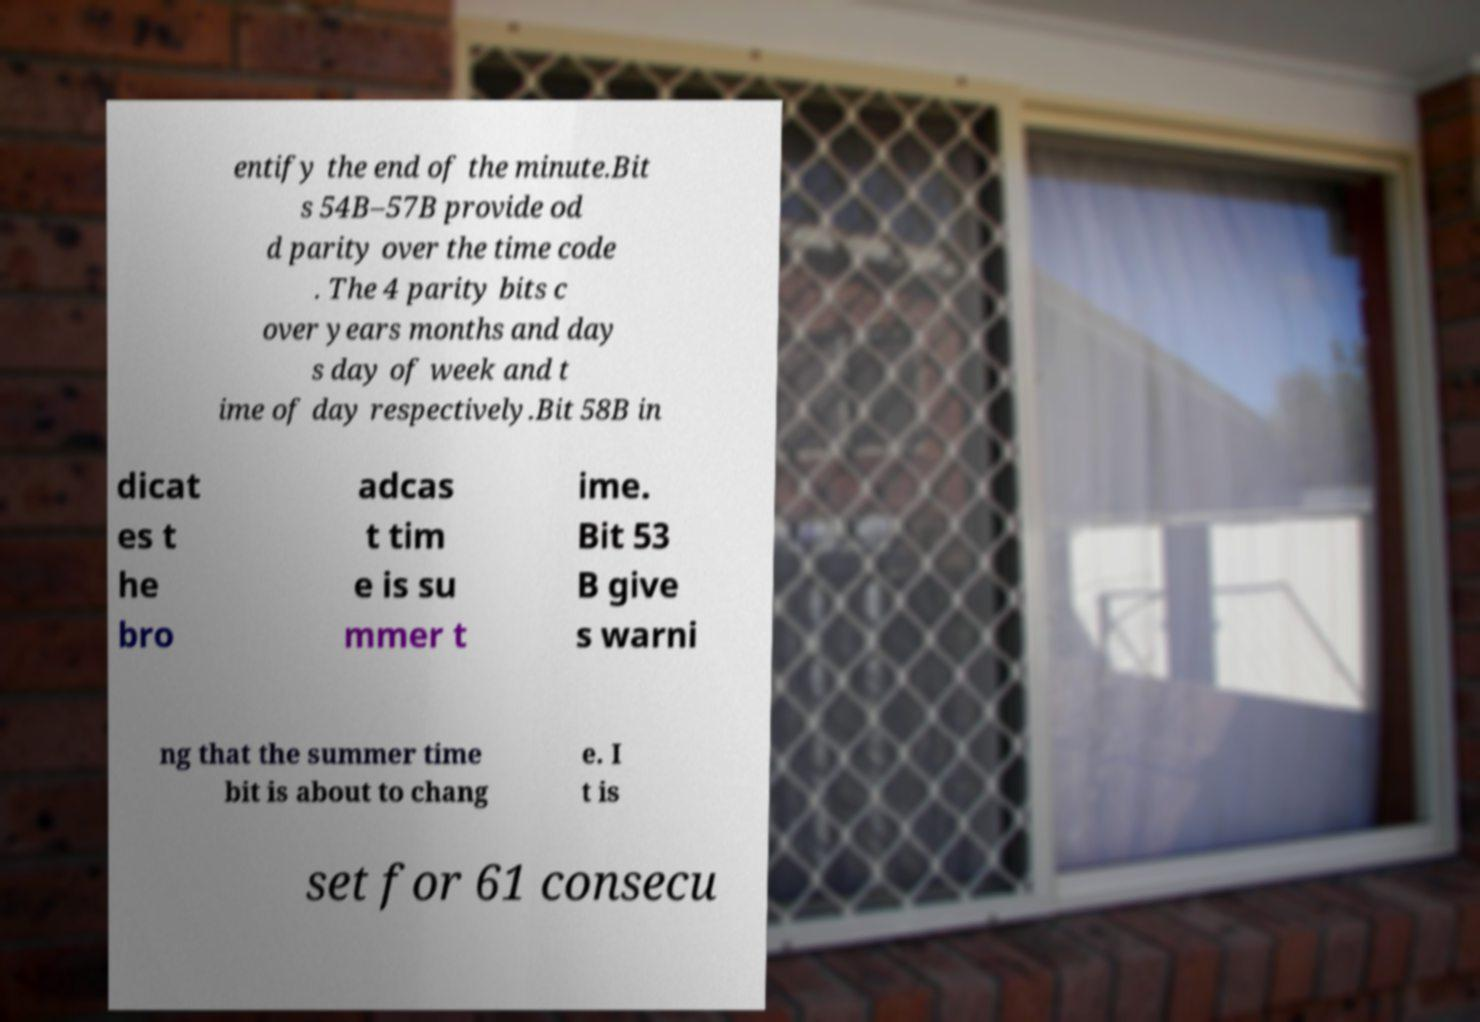Can you accurately transcribe the text from the provided image for me? entify the end of the minute.Bit s 54B–57B provide od d parity over the time code . The 4 parity bits c over years months and day s day of week and t ime of day respectively.Bit 58B in dicat es t he bro adcas t tim e is su mmer t ime. Bit 53 B give s warni ng that the summer time bit is about to chang e. I t is set for 61 consecu 